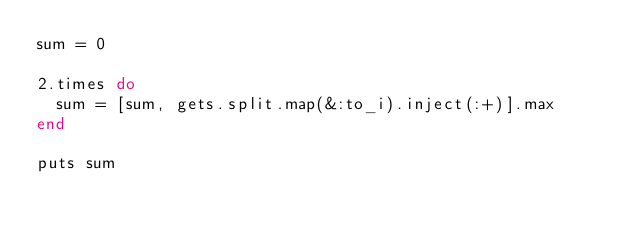Convert code to text. <code><loc_0><loc_0><loc_500><loc_500><_Ruby_>sum = 0

2.times do
  sum = [sum, gets.split.map(&:to_i).inject(:+)].max
end

puts sum</code> 